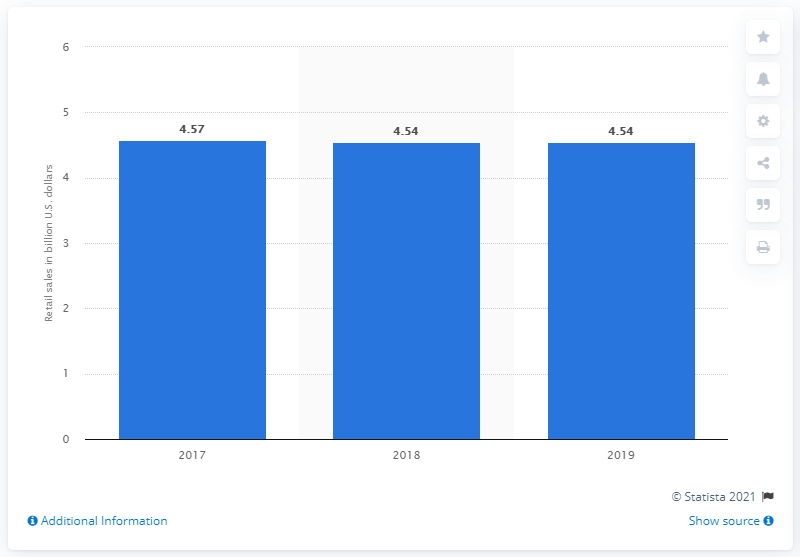Identify some key points in this picture. Neiman Marcus' retail sales in 2019 were 4.54 billion dollars. 